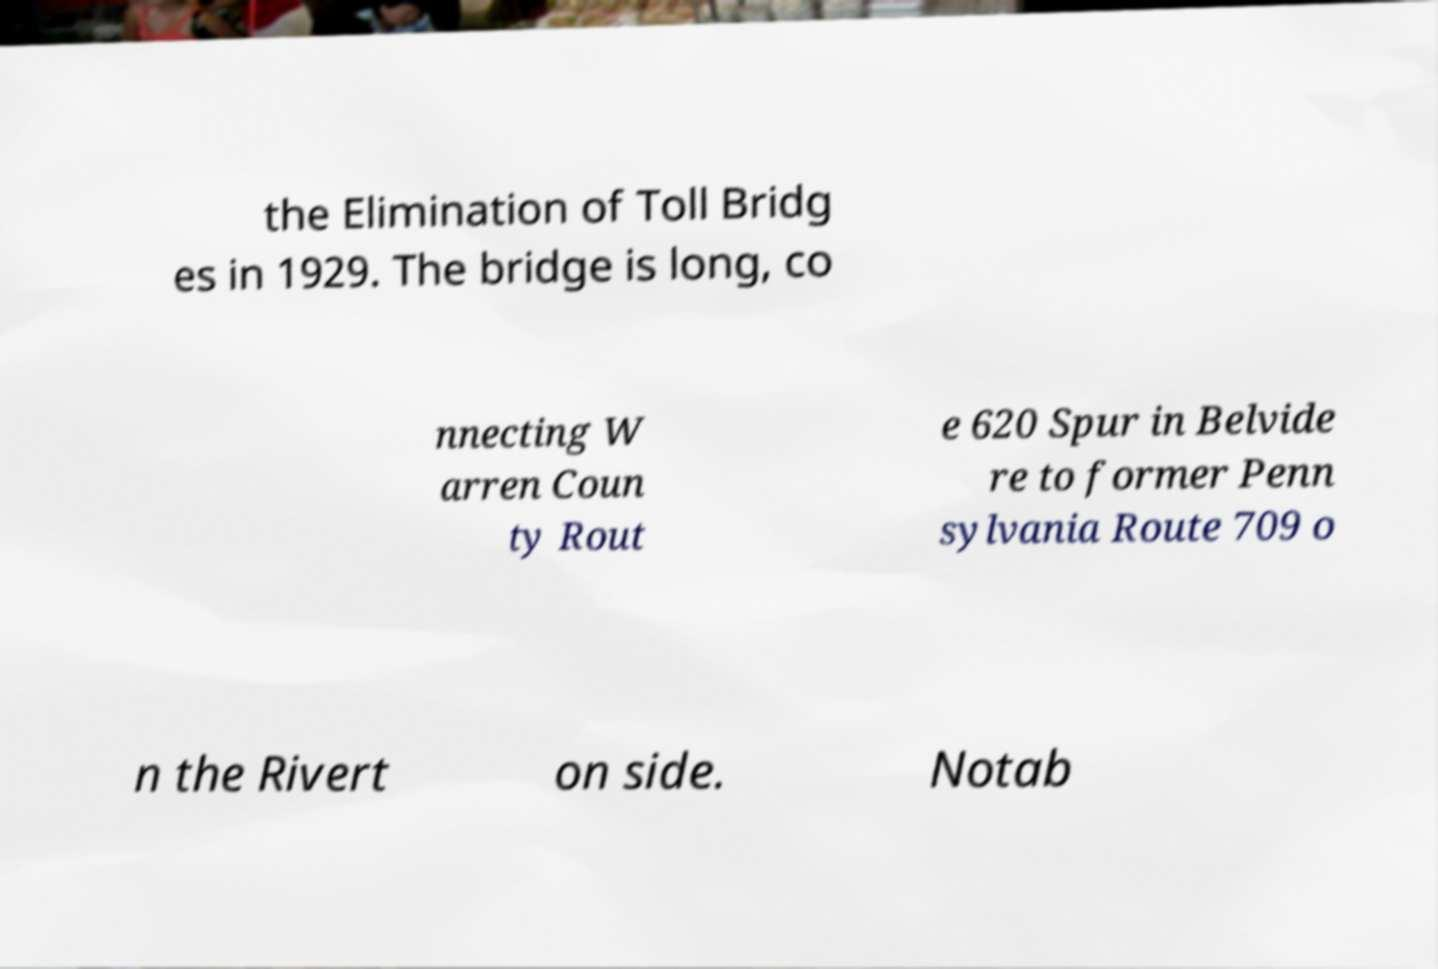Could you assist in decoding the text presented in this image and type it out clearly? the Elimination of Toll Bridg es in 1929. The bridge is long, co nnecting W arren Coun ty Rout e 620 Spur in Belvide re to former Penn sylvania Route 709 o n the Rivert on side. Notab 